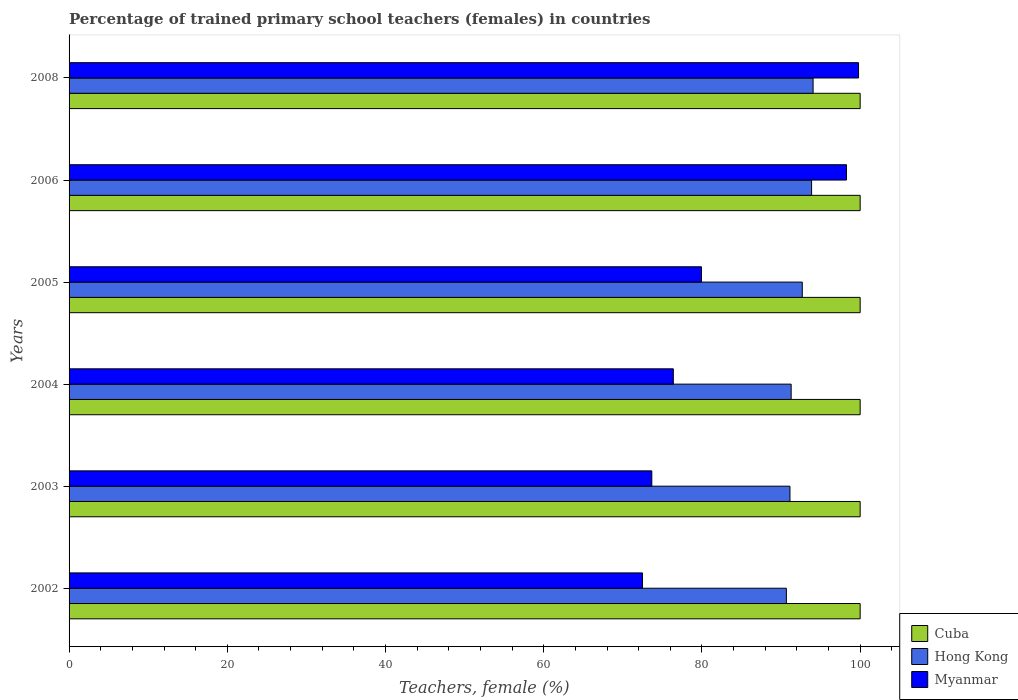How many different coloured bars are there?
Provide a succinct answer. 3. How many bars are there on the 4th tick from the top?
Offer a very short reply. 3. What is the label of the 6th group of bars from the top?
Offer a very short reply. 2002. In how many cases, is the number of bars for a given year not equal to the number of legend labels?
Offer a very short reply. 0. What is the percentage of trained primary school teachers (females) in Cuba in 2004?
Keep it short and to the point. 100. Across all years, what is the maximum percentage of trained primary school teachers (females) in Hong Kong?
Keep it short and to the point. 94.05. Across all years, what is the minimum percentage of trained primary school teachers (females) in Hong Kong?
Provide a succinct answer. 90.67. In which year was the percentage of trained primary school teachers (females) in Cuba maximum?
Give a very brief answer. 2002. In which year was the percentage of trained primary school teachers (females) in Cuba minimum?
Provide a short and direct response. 2002. What is the total percentage of trained primary school teachers (females) in Myanmar in the graph?
Offer a very short reply. 500.54. What is the difference between the percentage of trained primary school teachers (females) in Cuba in 2002 and that in 2003?
Provide a short and direct response. 0. What is the difference between the percentage of trained primary school teachers (females) in Hong Kong in 2003 and the percentage of trained primary school teachers (females) in Cuba in 2002?
Provide a succinct answer. -8.87. What is the average percentage of trained primary school teachers (females) in Myanmar per year?
Your answer should be very brief. 83.42. In the year 2008, what is the difference between the percentage of trained primary school teachers (females) in Hong Kong and percentage of trained primary school teachers (females) in Myanmar?
Your answer should be very brief. -5.75. What is the ratio of the percentage of trained primary school teachers (females) in Cuba in 2002 to that in 2005?
Offer a very short reply. 1. Is the percentage of trained primary school teachers (females) in Hong Kong in 2002 less than that in 2003?
Ensure brevity in your answer.  Yes. Is the difference between the percentage of trained primary school teachers (females) in Hong Kong in 2002 and 2006 greater than the difference between the percentage of trained primary school teachers (females) in Myanmar in 2002 and 2006?
Offer a very short reply. Yes. What is the difference between the highest and the lowest percentage of trained primary school teachers (females) in Hong Kong?
Offer a very short reply. 3.38. In how many years, is the percentage of trained primary school teachers (females) in Hong Kong greater than the average percentage of trained primary school teachers (females) in Hong Kong taken over all years?
Your answer should be very brief. 3. What does the 2nd bar from the top in 2002 represents?
Provide a short and direct response. Hong Kong. What does the 1st bar from the bottom in 2008 represents?
Provide a short and direct response. Cuba. How many bars are there?
Your response must be concise. 18. How many years are there in the graph?
Offer a very short reply. 6. What is the difference between two consecutive major ticks on the X-axis?
Provide a short and direct response. 20. Are the values on the major ticks of X-axis written in scientific E-notation?
Keep it short and to the point. No. Where does the legend appear in the graph?
Offer a very short reply. Bottom right. What is the title of the graph?
Make the answer very short. Percentage of trained primary school teachers (females) in countries. What is the label or title of the X-axis?
Provide a short and direct response. Teachers, female (%). What is the label or title of the Y-axis?
Your response must be concise. Years. What is the Teachers, female (%) in Cuba in 2002?
Offer a very short reply. 100. What is the Teachers, female (%) of Hong Kong in 2002?
Your answer should be very brief. 90.67. What is the Teachers, female (%) of Myanmar in 2002?
Offer a very short reply. 72.48. What is the Teachers, female (%) of Cuba in 2003?
Keep it short and to the point. 100. What is the Teachers, female (%) of Hong Kong in 2003?
Your response must be concise. 91.13. What is the Teachers, female (%) of Myanmar in 2003?
Your answer should be compact. 73.66. What is the Teachers, female (%) in Cuba in 2004?
Make the answer very short. 100. What is the Teachers, female (%) of Hong Kong in 2004?
Provide a short and direct response. 91.28. What is the Teachers, female (%) of Myanmar in 2004?
Your answer should be compact. 76.38. What is the Teachers, female (%) of Hong Kong in 2005?
Give a very brief answer. 92.68. What is the Teachers, female (%) in Myanmar in 2005?
Provide a short and direct response. 79.94. What is the Teachers, female (%) of Hong Kong in 2006?
Keep it short and to the point. 93.86. What is the Teachers, female (%) of Myanmar in 2006?
Your response must be concise. 98.27. What is the Teachers, female (%) in Cuba in 2008?
Your answer should be very brief. 100. What is the Teachers, female (%) of Hong Kong in 2008?
Keep it short and to the point. 94.05. What is the Teachers, female (%) in Myanmar in 2008?
Your answer should be compact. 99.8. Across all years, what is the maximum Teachers, female (%) in Cuba?
Your answer should be very brief. 100. Across all years, what is the maximum Teachers, female (%) in Hong Kong?
Ensure brevity in your answer.  94.05. Across all years, what is the maximum Teachers, female (%) in Myanmar?
Make the answer very short. 99.8. Across all years, what is the minimum Teachers, female (%) in Cuba?
Your answer should be compact. 100. Across all years, what is the minimum Teachers, female (%) of Hong Kong?
Provide a succinct answer. 90.67. Across all years, what is the minimum Teachers, female (%) of Myanmar?
Your answer should be very brief. 72.48. What is the total Teachers, female (%) of Cuba in the graph?
Offer a terse response. 600. What is the total Teachers, female (%) of Hong Kong in the graph?
Make the answer very short. 553.68. What is the total Teachers, female (%) in Myanmar in the graph?
Your response must be concise. 500.54. What is the difference between the Teachers, female (%) of Hong Kong in 2002 and that in 2003?
Provide a short and direct response. -0.45. What is the difference between the Teachers, female (%) in Myanmar in 2002 and that in 2003?
Provide a succinct answer. -1.18. What is the difference between the Teachers, female (%) of Cuba in 2002 and that in 2004?
Offer a very short reply. 0. What is the difference between the Teachers, female (%) in Hong Kong in 2002 and that in 2004?
Provide a short and direct response. -0.6. What is the difference between the Teachers, female (%) of Myanmar in 2002 and that in 2004?
Ensure brevity in your answer.  -3.9. What is the difference between the Teachers, female (%) of Cuba in 2002 and that in 2005?
Provide a succinct answer. 0. What is the difference between the Teachers, female (%) of Hong Kong in 2002 and that in 2005?
Your answer should be compact. -2.01. What is the difference between the Teachers, female (%) in Myanmar in 2002 and that in 2005?
Your response must be concise. -7.46. What is the difference between the Teachers, female (%) of Hong Kong in 2002 and that in 2006?
Offer a very short reply. -3.19. What is the difference between the Teachers, female (%) of Myanmar in 2002 and that in 2006?
Make the answer very short. -25.79. What is the difference between the Teachers, female (%) of Hong Kong in 2002 and that in 2008?
Give a very brief answer. -3.38. What is the difference between the Teachers, female (%) of Myanmar in 2002 and that in 2008?
Your answer should be very brief. -27.31. What is the difference between the Teachers, female (%) in Hong Kong in 2003 and that in 2004?
Your answer should be compact. -0.15. What is the difference between the Teachers, female (%) of Myanmar in 2003 and that in 2004?
Your response must be concise. -2.72. What is the difference between the Teachers, female (%) in Cuba in 2003 and that in 2005?
Your response must be concise. 0. What is the difference between the Teachers, female (%) in Hong Kong in 2003 and that in 2005?
Offer a very short reply. -1.56. What is the difference between the Teachers, female (%) of Myanmar in 2003 and that in 2005?
Give a very brief answer. -6.28. What is the difference between the Teachers, female (%) of Cuba in 2003 and that in 2006?
Offer a terse response. 0. What is the difference between the Teachers, female (%) in Hong Kong in 2003 and that in 2006?
Make the answer very short. -2.74. What is the difference between the Teachers, female (%) in Myanmar in 2003 and that in 2006?
Make the answer very short. -24.61. What is the difference between the Teachers, female (%) in Cuba in 2003 and that in 2008?
Provide a succinct answer. 0. What is the difference between the Teachers, female (%) of Hong Kong in 2003 and that in 2008?
Keep it short and to the point. -2.92. What is the difference between the Teachers, female (%) of Myanmar in 2003 and that in 2008?
Provide a succinct answer. -26.13. What is the difference between the Teachers, female (%) of Cuba in 2004 and that in 2005?
Keep it short and to the point. 0. What is the difference between the Teachers, female (%) in Hong Kong in 2004 and that in 2005?
Keep it short and to the point. -1.41. What is the difference between the Teachers, female (%) of Myanmar in 2004 and that in 2005?
Your answer should be very brief. -3.56. What is the difference between the Teachers, female (%) in Cuba in 2004 and that in 2006?
Keep it short and to the point. 0. What is the difference between the Teachers, female (%) in Hong Kong in 2004 and that in 2006?
Your answer should be compact. -2.58. What is the difference between the Teachers, female (%) in Myanmar in 2004 and that in 2006?
Keep it short and to the point. -21.89. What is the difference between the Teachers, female (%) in Hong Kong in 2004 and that in 2008?
Your answer should be very brief. -2.77. What is the difference between the Teachers, female (%) of Myanmar in 2004 and that in 2008?
Offer a very short reply. -23.41. What is the difference between the Teachers, female (%) of Cuba in 2005 and that in 2006?
Keep it short and to the point. 0. What is the difference between the Teachers, female (%) in Hong Kong in 2005 and that in 2006?
Your response must be concise. -1.18. What is the difference between the Teachers, female (%) in Myanmar in 2005 and that in 2006?
Keep it short and to the point. -18.33. What is the difference between the Teachers, female (%) of Cuba in 2005 and that in 2008?
Your response must be concise. 0. What is the difference between the Teachers, female (%) in Hong Kong in 2005 and that in 2008?
Provide a succinct answer. -1.37. What is the difference between the Teachers, female (%) of Myanmar in 2005 and that in 2008?
Your answer should be very brief. -19.86. What is the difference between the Teachers, female (%) in Hong Kong in 2006 and that in 2008?
Make the answer very short. -0.19. What is the difference between the Teachers, female (%) in Myanmar in 2006 and that in 2008?
Provide a succinct answer. -1.52. What is the difference between the Teachers, female (%) in Cuba in 2002 and the Teachers, female (%) in Hong Kong in 2003?
Provide a short and direct response. 8.87. What is the difference between the Teachers, female (%) in Cuba in 2002 and the Teachers, female (%) in Myanmar in 2003?
Provide a short and direct response. 26.34. What is the difference between the Teachers, female (%) of Hong Kong in 2002 and the Teachers, female (%) of Myanmar in 2003?
Ensure brevity in your answer.  17.01. What is the difference between the Teachers, female (%) in Cuba in 2002 and the Teachers, female (%) in Hong Kong in 2004?
Your answer should be compact. 8.72. What is the difference between the Teachers, female (%) in Cuba in 2002 and the Teachers, female (%) in Myanmar in 2004?
Provide a succinct answer. 23.62. What is the difference between the Teachers, female (%) in Hong Kong in 2002 and the Teachers, female (%) in Myanmar in 2004?
Your response must be concise. 14.29. What is the difference between the Teachers, female (%) of Cuba in 2002 and the Teachers, female (%) of Hong Kong in 2005?
Offer a very short reply. 7.32. What is the difference between the Teachers, female (%) in Cuba in 2002 and the Teachers, female (%) in Myanmar in 2005?
Provide a succinct answer. 20.06. What is the difference between the Teachers, female (%) of Hong Kong in 2002 and the Teachers, female (%) of Myanmar in 2005?
Provide a succinct answer. 10.73. What is the difference between the Teachers, female (%) of Cuba in 2002 and the Teachers, female (%) of Hong Kong in 2006?
Provide a succinct answer. 6.14. What is the difference between the Teachers, female (%) in Cuba in 2002 and the Teachers, female (%) in Myanmar in 2006?
Make the answer very short. 1.73. What is the difference between the Teachers, female (%) of Hong Kong in 2002 and the Teachers, female (%) of Myanmar in 2006?
Ensure brevity in your answer.  -7.6. What is the difference between the Teachers, female (%) in Cuba in 2002 and the Teachers, female (%) in Hong Kong in 2008?
Your answer should be very brief. 5.95. What is the difference between the Teachers, female (%) of Cuba in 2002 and the Teachers, female (%) of Myanmar in 2008?
Make the answer very short. 0.2. What is the difference between the Teachers, female (%) of Hong Kong in 2002 and the Teachers, female (%) of Myanmar in 2008?
Provide a succinct answer. -9.12. What is the difference between the Teachers, female (%) of Cuba in 2003 and the Teachers, female (%) of Hong Kong in 2004?
Offer a very short reply. 8.72. What is the difference between the Teachers, female (%) of Cuba in 2003 and the Teachers, female (%) of Myanmar in 2004?
Ensure brevity in your answer.  23.62. What is the difference between the Teachers, female (%) of Hong Kong in 2003 and the Teachers, female (%) of Myanmar in 2004?
Provide a succinct answer. 14.74. What is the difference between the Teachers, female (%) in Cuba in 2003 and the Teachers, female (%) in Hong Kong in 2005?
Ensure brevity in your answer.  7.32. What is the difference between the Teachers, female (%) of Cuba in 2003 and the Teachers, female (%) of Myanmar in 2005?
Your answer should be compact. 20.06. What is the difference between the Teachers, female (%) of Hong Kong in 2003 and the Teachers, female (%) of Myanmar in 2005?
Ensure brevity in your answer.  11.19. What is the difference between the Teachers, female (%) in Cuba in 2003 and the Teachers, female (%) in Hong Kong in 2006?
Your response must be concise. 6.14. What is the difference between the Teachers, female (%) of Cuba in 2003 and the Teachers, female (%) of Myanmar in 2006?
Provide a short and direct response. 1.73. What is the difference between the Teachers, female (%) of Hong Kong in 2003 and the Teachers, female (%) of Myanmar in 2006?
Make the answer very short. -7.15. What is the difference between the Teachers, female (%) of Cuba in 2003 and the Teachers, female (%) of Hong Kong in 2008?
Keep it short and to the point. 5.95. What is the difference between the Teachers, female (%) in Cuba in 2003 and the Teachers, female (%) in Myanmar in 2008?
Your answer should be compact. 0.2. What is the difference between the Teachers, female (%) of Hong Kong in 2003 and the Teachers, female (%) of Myanmar in 2008?
Keep it short and to the point. -8.67. What is the difference between the Teachers, female (%) of Cuba in 2004 and the Teachers, female (%) of Hong Kong in 2005?
Keep it short and to the point. 7.32. What is the difference between the Teachers, female (%) of Cuba in 2004 and the Teachers, female (%) of Myanmar in 2005?
Provide a short and direct response. 20.06. What is the difference between the Teachers, female (%) of Hong Kong in 2004 and the Teachers, female (%) of Myanmar in 2005?
Ensure brevity in your answer.  11.34. What is the difference between the Teachers, female (%) in Cuba in 2004 and the Teachers, female (%) in Hong Kong in 2006?
Offer a terse response. 6.14. What is the difference between the Teachers, female (%) in Cuba in 2004 and the Teachers, female (%) in Myanmar in 2006?
Provide a short and direct response. 1.73. What is the difference between the Teachers, female (%) in Hong Kong in 2004 and the Teachers, female (%) in Myanmar in 2006?
Your response must be concise. -7. What is the difference between the Teachers, female (%) in Cuba in 2004 and the Teachers, female (%) in Hong Kong in 2008?
Make the answer very short. 5.95. What is the difference between the Teachers, female (%) in Cuba in 2004 and the Teachers, female (%) in Myanmar in 2008?
Provide a short and direct response. 0.2. What is the difference between the Teachers, female (%) in Hong Kong in 2004 and the Teachers, female (%) in Myanmar in 2008?
Your response must be concise. -8.52. What is the difference between the Teachers, female (%) in Cuba in 2005 and the Teachers, female (%) in Hong Kong in 2006?
Your answer should be very brief. 6.14. What is the difference between the Teachers, female (%) of Cuba in 2005 and the Teachers, female (%) of Myanmar in 2006?
Offer a very short reply. 1.73. What is the difference between the Teachers, female (%) in Hong Kong in 2005 and the Teachers, female (%) in Myanmar in 2006?
Keep it short and to the point. -5.59. What is the difference between the Teachers, female (%) of Cuba in 2005 and the Teachers, female (%) of Hong Kong in 2008?
Your answer should be very brief. 5.95. What is the difference between the Teachers, female (%) of Cuba in 2005 and the Teachers, female (%) of Myanmar in 2008?
Offer a terse response. 0.2. What is the difference between the Teachers, female (%) in Hong Kong in 2005 and the Teachers, female (%) in Myanmar in 2008?
Make the answer very short. -7.11. What is the difference between the Teachers, female (%) in Cuba in 2006 and the Teachers, female (%) in Hong Kong in 2008?
Offer a terse response. 5.95. What is the difference between the Teachers, female (%) of Cuba in 2006 and the Teachers, female (%) of Myanmar in 2008?
Ensure brevity in your answer.  0.2. What is the difference between the Teachers, female (%) in Hong Kong in 2006 and the Teachers, female (%) in Myanmar in 2008?
Give a very brief answer. -5.93. What is the average Teachers, female (%) of Cuba per year?
Your response must be concise. 100. What is the average Teachers, female (%) of Hong Kong per year?
Keep it short and to the point. 92.28. What is the average Teachers, female (%) in Myanmar per year?
Your answer should be very brief. 83.42. In the year 2002, what is the difference between the Teachers, female (%) of Cuba and Teachers, female (%) of Hong Kong?
Provide a short and direct response. 9.33. In the year 2002, what is the difference between the Teachers, female (%) in Cuba and Teachers, female (%) in Myanmar?
Give a very brief answer. 27.52. In the year 2002, what is the difference between the Teachers, female (%) of Hong Kong and Teachers, female (%) of Myanmar?
Offer a very short reply. 18.19. In the year 2003, what is the difference between the Teachers, female (%) in Cuba and Teachers, female (%) in Hong Kong?
Give a very brief answer. 8.87. In the year 2003, what is the difference between the Teachers, female (%) of Cuba and Teachers, female (%) of Myanmar?
Provide a short and direct response. 26.34. In the year 2003, what is the difference between the Teachers, female (%) in Hong Kong and Teachers, female (%) in Myanmar?
Your response must be concise. 17.46. In the year 2004, what is the difference between the Teachers, female (%) in Cuba and Teachers, female (%) in Hong Kong?
Your response must be concise. 8.72. In the year 2004, what is the difference between the Teachers, female (%) in Cuba and Teachers, female (%) in Myanmar?
Your answer should be compact. 23.62. In the year 2004, what is the difference between the Teachers, female (%) of Hong Kong and Teachers, female (%) of Myanmar?
Your answer should be very brief. 14.89. In the year 2005, what is the difference between the Teachers, female (%) in Cuba and Teachers, female (%) in Hong Kong?
Keep it short and to the point. 7.32. In the year 2005, what is the difference between the Teachers, female (%) in Cuba and Teachers, female (%) in Myanmar?
Offer a very short reply. 20.06. In the year 2005, what is the difference between the Teachers, female (%) in Hong Kong and Teachers, female (%) in Myanmar?
Your answer should be very brief. 12.75. In the year 2006, what is the difference between the Teachers, female (%) of Cuba and Teachers, female (%) of Hong Kong?
Provide a short and direct response. 6.14. In the year 2006, what is the difference between the Teachers, female (%) of Cuba and Teachers, female (%) of Myanmar?
Your answer should be very brief. 1.73. In the year 2006, what is the difference between the Teachers, female (%) of Hong Kong and Teachers, female (%) of Myanmar?
Your answer should be compact. -4.41. In the year 2008, what is the difference between the Teachers, female (%) of Cuba and Teachers, female (%) of Hong Kong?
Your answer should be compact. 5.95. In the year 2008, what is the difference between the Teachers, female (%) of Cuba and Teachers, female (%) of Myanmar?
Offer a terse response. 0.2. In the year 2008, what is the difference between the Teachers, female (%) in Hong Kong and Teachers, female (%) in Myanmar?
Give a very brief answer. -5.75. What is the ratio of the Teachers, female (%) of Cuba in 2002 to that in 2003?
Provide a succinct answer. 1. What is the ratio of the Teachers, female (%) of Cuba in 2002 to that in 2004?
Ensure brevity in your answer.  1. What is the ratio of the Teachers, female (%) in Myanmar in 2002 to that in 2004?
Your answer should be compact. 0.95. What is the ratio of the Teachers, female (%) of Hong Kong in 2002 to that in 2005?
Provide a short and direct response. 0.98. What is the ratio of the Teachers, female (%) in Myanmar in 2002 to that in 2005?
Your response must be concise. 0.91. What is the ratio of the Teachers, female (%) of Hong Kong in 2002 to that in 2006?
Provide a succinct answer. 0.97. What is the ratio of the Teachers, female (%) in Myanmar in 2002 to that in 2006?
Make the answer very short. 0.74. What is the ratio of the Teachers, female (%) of Hong Kong in 2002 to that in 2008?
Your answer should be compact. 0.96. What is the ratio of the Teachers, female (%) in Myanmar in 2002 to that in 2008?
Offer a terse response. 0.73. What is the ratio of the Teachers, female (%) in Cuba in 2003 to that in 2004?
Ensure brevity in your answer.  1. What is the ratio of the Teachers, female (%) of Myanmar in 2003 to that in 2004?
Provide a short and direct response. 0.96. What is the ratio of the Teachers, female (%) of Cuba in 2003 to that in 2005?
Make the answer very short. 1. What is the ratio of the Teachers, female (%) in Hong Kong in 2003 to that in 2005?
Your response must be concise. 0.98. What is the ratio of the Teachers, female (%) of Myanmar in 2003 to that in 2005?
Provide a succinct answer. 0.92. What is the ratio of the Teachers, female (%) of Hong Kong in 2003 to that in 2006?
Offer a very short reply. 0.97. What is the ratio of the Teachers, female (%) of Myanmar in 2003 to that in 2006?
Your answer should be very brief. 0.75. What is the ratio of the Teachers, female (%) in Cuba in 2003 to that in 2008?
Your answer should be very brief. 1. What is the ratio of the Teachers, female (%) in Hong Kong in 2003 to that in 2008?
Give a very brief answer. 0.97. What is the ratio of the Teachers, female (%) in Myanmar in 2003 to that in 2008?
Your answer should be very brief. 0.74. What is the ratio of the Teachers, female (%) in Cuba in 2004 to that in 2005?
Give a very brief answer. 1. What is the ratio of the Teachers, female (%) of Myanmar in 2004 to that in 2005?
Offer a very short reply. 0.96. What is the ratio of the Teachers, female (%) of Cuba in 2004 to that in 2006?
Keep it short and to the point. 1. What is the ratio of the Teachers, female (%) of Hong Kong in 2004 to that in 2006?
Keep it short and to the point. 0.97. What is the ratio of the Teachers, female (%) in Myanmar in 2004 to that in 2006?
Offer a terse response. 0.78. What is the ratio of the Teachers, female (%) in Cuba in 2004 to that in 2008?
Make the answer very short. 1. What is the ratio of the Teachers, female (%) of Hong Kong in 2004 to that in 2008?
Your answer should be very brief. 0.97. What is the ratio of the Teachers, female (%) in Myanmar in 2004 to that in 2008?
Ensure brevity in your answer.  0.77. What is the ratio of the Teachers, female (%) in Hong Kong in 2005 to that in 2006?
Provide a succinct answer. 0.99. What is the ratio of the Teachers, female (%) in Myanmar in 2005 to that in 2006?
Ensure brevity in your answer.  0.81. What is the ratio of the Teachers, female (%) in Hong Kong in 2005 to that in 2008?
Give a very brief answer. 0.99. What is the ratio of the Teachers, female (%) in Myanmar in 2005 to that in 2008?
Make the answer very short. 0.8. What is the ratio of the Teachers, female (%) in Cuba in 2006 to that in 2008?
Give a very brief answer. 1. What is the ratio of the Teachers, female (%) in Hong Kong in 2006 to that in 2008?
Provide a short and direct response. 1. What is the ratio of the Teachers, female (%) in Myanmar in 2006 to that in 2008?
Keep it short and to the point. 0.98. What is the difference between the highest and the second highest Teachers, female (%) of Cuba?
Offer a very short reply. 0. What is the difference between the highest and the second highest Teachers, female (%) in Hong Kong?
Keep it short and to the point. 0.19. What is the difference between the highest and the second highest Teachers, female (%) in Myanmar?
Provide a short and direct response. 1.52. What is the difference between the highest and the lowest Teachers, female (%) in Hong Kong?
Provide a short and direct response. 3.38. What is the difference between the highest and the lowest Teachers, female (%) of Myanmar?
Your response must be concise. 27.31. 